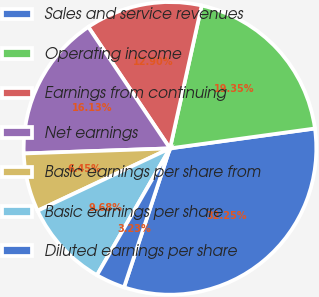Convert chart. <chart><loc_0><loc_0><loc_500><loc_500><pie_chart><fcel>Sales and service revenues<fcel>Operating income<fcel>Earnings from continuing<fcel>Net earnings<fcel>Basic earnings per share from<fcel>Basic earnings per share<fcel>Diluted earnings per share<nl><fcel>32.25%<fcel>19.35%<fcel>12.9%<fcel>16.13%<fcel>6.45%<fcel>9.68%<fcel>3.23%<nl></chart> 